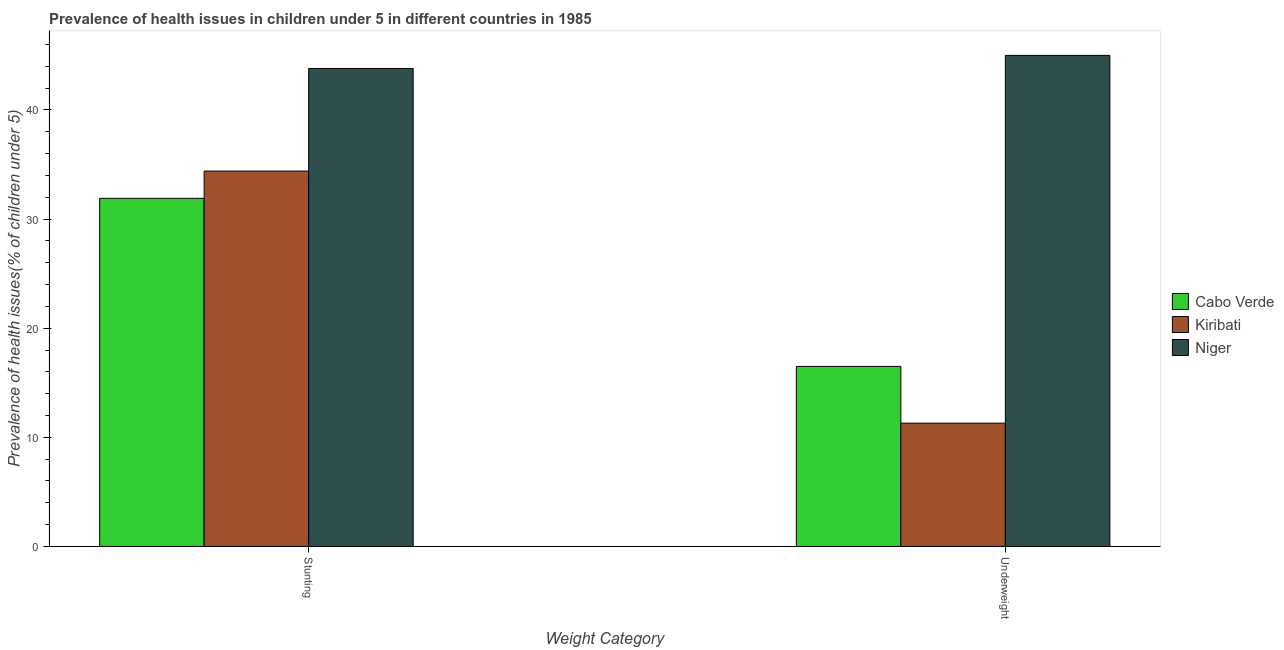How many different coloured bars are there?
Ensure brevity in your answer.  3. Are the number of bars per tick equal to the number of legend labels?
Ensure brevity in your answer.  Yes. Are the number of bars on each tick of the X-axis equal?
Make the answer very short. Yes. How many bars are there on the 2nd tick from the left?
Offer a very short reply. 3. What is the label of the 2nd group of bars from the left?
Ensure brevity in your answer.  Underweight. What is the percentage of stunted children in Kiribati?
Offer a terse response. 34.4. Across all countries, what is the maximum percentage of stunted children?
Provide a short and direct response. 43.8. Across all countries, what is the minimum percentage of underweight children?
Keep it short and to the point. 11.3. In which country was the percentage of underweight children maximum?
Offer a very short reply. Niger. In which country was the percentage of underweight children minimum?
Provide a succinct answer. Kiribati. What is the total percentage of underweight children in the graph?
Your response must be concise. 72.8. What is the difference between the percentage of stunted children in Kiribati and that in Niger?
Your answer should be compact. -9.4. What is the difference between the percentage of stunted children in Cabo Verde and the percentage of underweight children in Kiribati?
Your answer should be very brief. 20.6. What is the average percentage of underweight children per country?
Offer a terse response. 24.27. What is the difference between the percentage of stunted children and percentage of underweight children in Kiribati?
Provide a short and direct response. 23.1. What is the ratio of the percentage of stunted children in Kiribati to that in Cabo Verde?
Your answer should be compact. 1.08. In how many countries, is the percentage of underweight children greater than the average percentage of underweight children taken over all countries?
Provide a succinct answer. 1. What does the 1st bar from the left in Stunting represents?
Keep it short and to the point. Cabo Verde. What does the 2nd bar from the right in Stunting represents?
Provide a succinct answer. Kiribati. Are all the bars in the graph horizontal?
Offer a terse response. No. What is the difference between two consecutive major ticks on the Y-axis?
Your answer should be very brief. 10. Are the values on the major ticks of Y-axis written in scientific E-notation?
Ensure brevity in your answer.  No. Does the graph contain any zero values?
Offer a very short reply. No. Does the graph contain grids?
Provide a succinct answer. No. Where does the legend appear in the graph?
Ensure brevity in your answer.  Center right. How many legend labels are there?
Offer a very short reply. 3. How are the legend labels stacked?
Your answer should be compact. Vertical. What is the title of the graph?
Offer a terse response. Prevalence of health issues in children under 5 in different countries in 1985. What is the label or title of the X-axis?
Keep it short and to the point. Weight Category. What is the label or title of the Y-axis?
Your answer should be very brief. Prevalence of health issues(% of children under 5). What is the Prevalence of health issues(% of children under 5) of Cabo Verde in Stunting?
Provide a succinct answer. 31.9. What is the Prevalence of health issues(% of children under 5) of Kiribati in Stunting?
Your answer should be very brief. 34.4. What is the Prevalence of health issues(% of children under 5) of Niger in Stunting?
Provide a succinct answer. 43.8. What is the Prevalence of health issues(% of children under 5) of Kiribati in Underweight?
Give a very brief answer. 11.3. What is the Prevalence of health issues(% of children under 5) of Niger in Underweight?
Make the answer very short. 45. Across all Weight Category, what is the maximum Prevalence of health issues(% of children under 5) in Cabo Verde?
Ensure brevity in your answer.  31.9. Across all Weight Category, what is the maximum Prevalence of health issues(% of children under 5) in Kiribati?
Your response must be concise. 34.4. Across all Weight Category, what is the maximum Prevalence of health issues(% of children under 5) of Niger?
Give a very brief answer. 45. Across all Weight Category, what is the minimum Prevalence of health issues(% of children under 5) of Cabo Verde?
Offer a very short reply. 16.5. Across all Weight Category, what is the minimum Prevalence of health issues(% of children under 5) of Kiribati?
Your response must be concise. 11.3. Across all Weight Category, what is the minimum Prevalence of health issues(% of children under 5) in Niger?
Make the answer very short. 43.8. What is the total Prevalence of health issues(% of children under 5) of Cabo Verde in the graph?
Offer a very short reply. 48.4. What is the total Prevalence of health issues(% of children under 5) of Kiribati in the graph?
Offer a very short reply. 45.7. What is the total Prevalence of health issues(% of children under 5) of Niger in the graph?
Keep it short and to the point. 88.8. What is the difference between the Prevalence of health issues(% of children under 5) in Cabo Verde in Stunting and that in Underweight?
Your answer should be very brief. 15.4. What is the difference between the Prevalence of health issues(% of children under 5) in Kiribati in Stunting and that in Underweight?
Your answer should be very brief. 23.1. What is the difference between the Prevalence of health issues(% of children under 5) in Niger in Stunting and that in Underweight?
Make the answer very short. -1.2. What is the difference between the Prevalence of health issues(% of children under 5) in Cabo Verde in Stunting and the Prevalence of health issues(% of children under 5) in Kiribati in Underweight?
Your response must be concise. 20.6. What is the difference between the Prevalence of health issues(% of children under 5) of Cabo Verde in Stunting and the Prevalence of health issues(% of children under 5) of Niger in Underweight?
Your answer should be very brief. -13.1. What is the difference between the Prevalence of health issues(% of children under 5) of Kiribati in Stunting and the Prevalence of health issues(% of children under 5) of Niger in Underweight?
Make the answer very short. -10.6. What is the average Prevalence of health issues(% of children under 5) in Cabo Verde per Weight Category?
Offer a terse response. 24.2. What is the average Prevalence of health issues(% of children under 5) in Kiribati per Weight Category?
Offer a very short reply. 22.85. What is the average Prevalence of health issues(% of children under 5) in Niger per Weight Category?
Give a very brief answer. 44.4. What is the difference between the Prevalence of health issues(% of children under 5) in Cabo Verde and Prevalence of health issues(% of children under 5) in Kiribati in Stunting?
Your response must be concise. -2.5. What is the difference between the Prevalence of health issues(% of children under 5) in Cabo Verde and Prevalence of health issues(% of children under 5) in Niger in Underweight?
Ensure brevity in your answer.  -28.5. What is the difference between the Prevalence of health issues(% of children under 5) in Kiribati and Prevalence of health issues(% of children under 5) in Niger in Underweight?
Your response must be concise. -33.7. What is the ratio of the Prevalence of health issues(% of children under 5) in Cabo Verde in Stunting to that in Underweight?
Make the answer very short. 1.93. What is the ratio of the Prevalence of health issues(% of children under 5) in Kiribati in Stunting to that in Underweight?
Make the answer very short. 3.04. What is the ratio of the Prevalence of health issues(% of children under 5) in Niger in Stunting to that in Underweight?
Ensure brevity in your answer.  0.97. What is the difference between the highest and the second highest Prevalence of health issues(% of children under 5) of Kiribati?
Your answer should be compact. 23.1. What is the difference between the highest and the lowest Prevalence of health issues(% of children under 5) of Cabo Verde?
Offer a very short reply. 15.4. What is the difference between the highest and the lowest Prevalence of health issues(% of children under 5) of Kiribati?
Your answer should be compact. 23.1. 